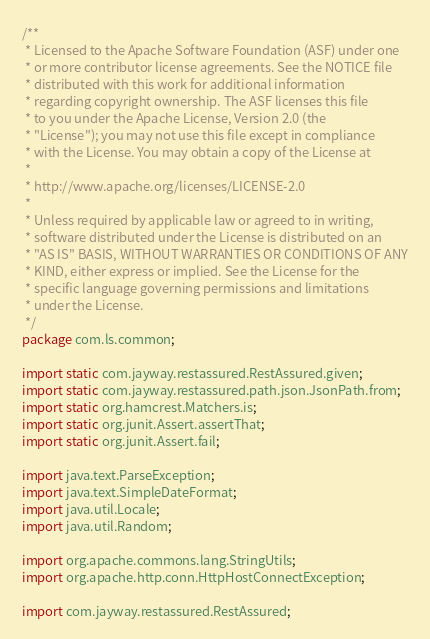<code> <loc_0><loc_0><loc_500><loc_500><_Java_>/**
 * Licensed to the Apache Software Foundation (ASF) under one
 * or more contributor license agreements. See the NOTICE file
 * distributed with this work for additional information
 * regarding copyright ownership. The ASF licenses this file
 * to you under the Apache License, Version 2.0 (the
 * "License"); you may not use this file except in compliance
 * with the License. You may obtain a copy of the License at
 *
 * http://www.apache.org/licenses/LICENSE-2.0
 *
 * Unless required by applicable law or agreed to in writing,
 * software distributed under the License is distributed on an
 * "AS IS" BASIS, WITHOUT WARRANTIES OR CONDITIONS OF ANY
 * KIND, either express or implied. See the License for the
 * specific language governing permissions and limitations
 * under the License.
 */
package com.ls.common;

import static com.jayway.restassured.RestAssured.given;
import static com.jayway.restassured.path.json.JsonPath.from;
import static org.hamcrest.Matchers.is;
import static org.junit.Assert.assertThat;
import static org.junit.Assert.fail;

import java.text.ParseException;
import java.text.SimpleDateFormat;
import java.util.Locale;
import java.util.Random;

import org.apache.commons.lang.StringUtils;
import org.apache.http.conn.HttpHostConnectException;

import com.jayway.restassured.RestAssured;</code> 